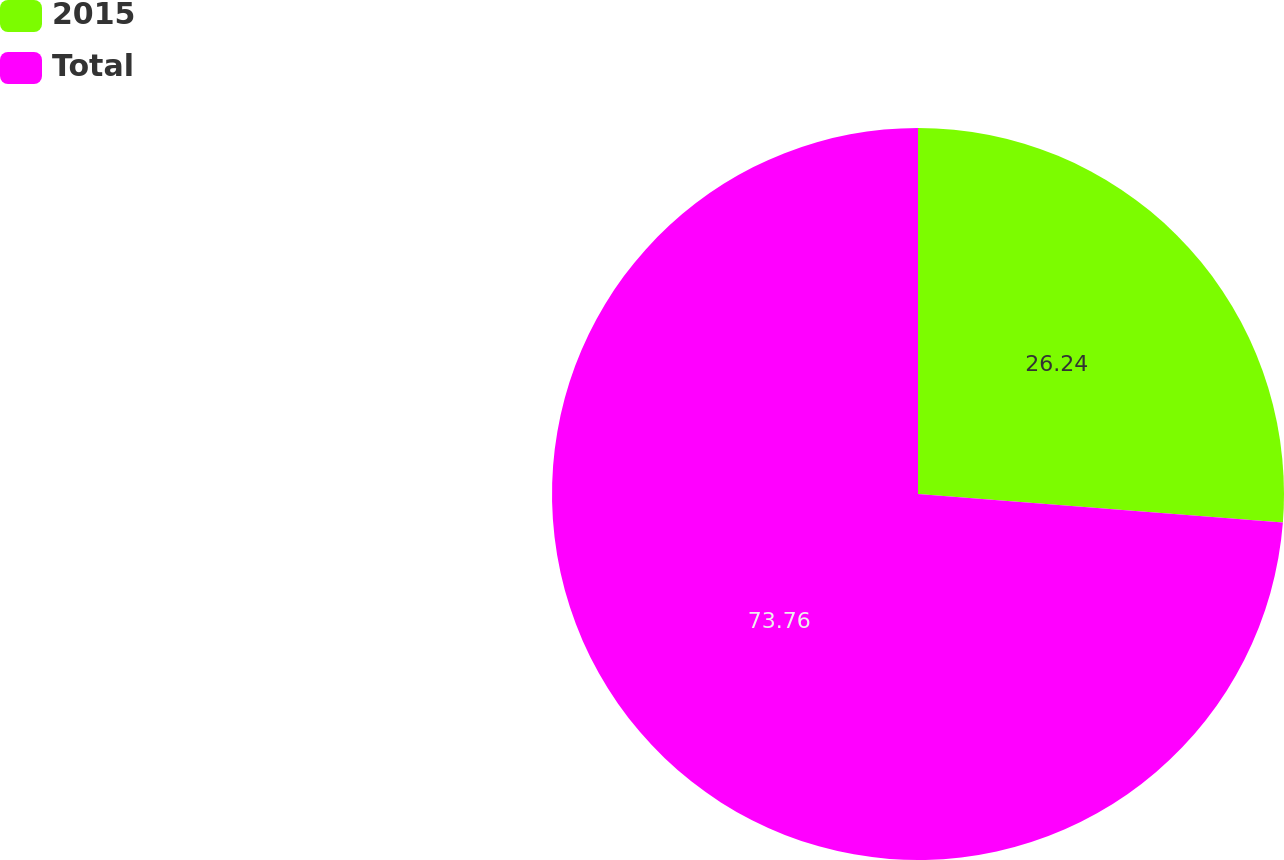Convert chart to OTSL. <chart><loc_0><loc_0><loc_500><loc_500><pie_chart><fcel>2015<fcel>Total<nl><fcel>26.24%<fcel>73.76%<nl></chart> 